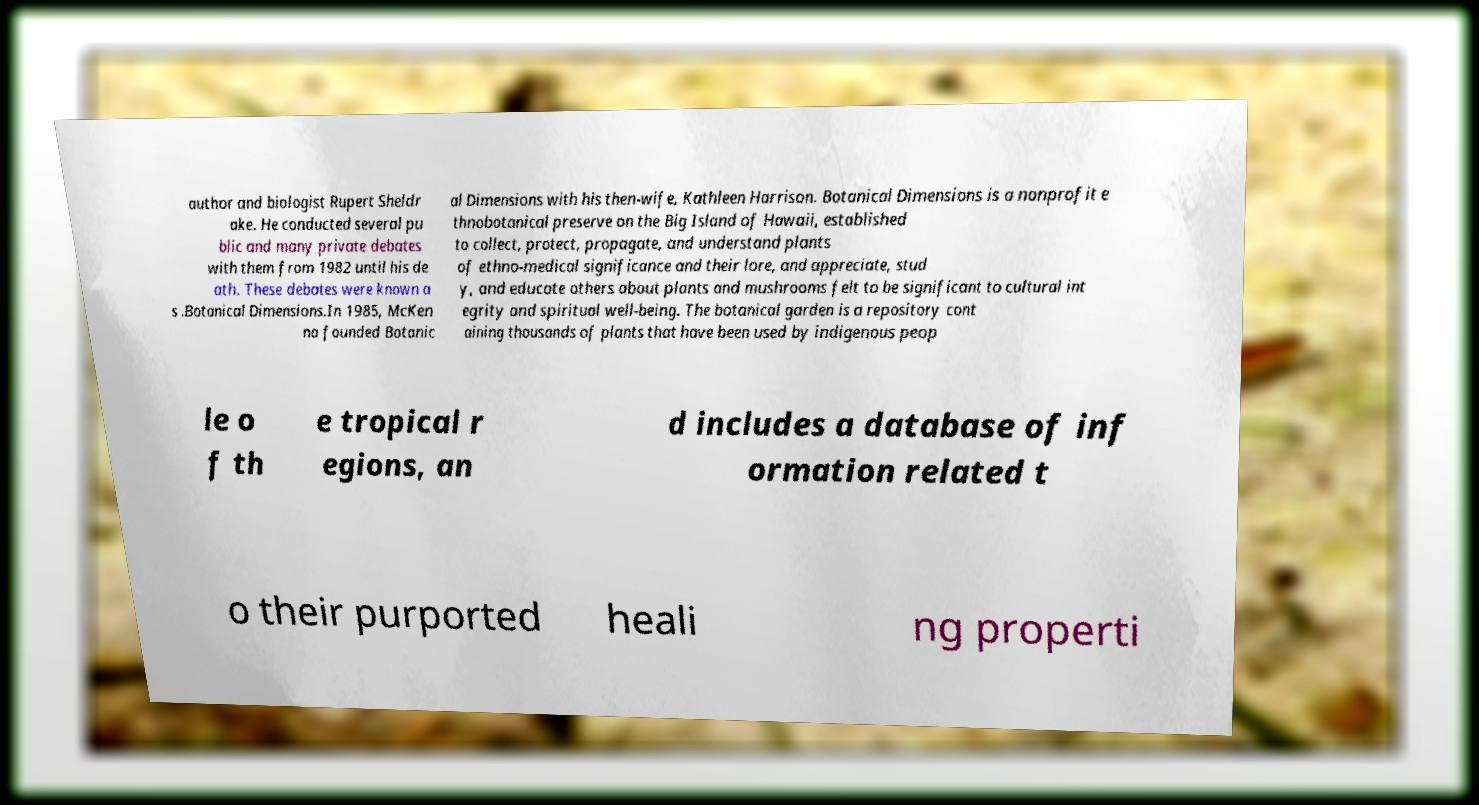Could you assist in decoding the text presented in this image and type it out clearly? author and biologist Rupert Sheldr ake. He conducted several pu blic and many private debates with them from 1982 until his de ath. These debates were known a s .Botanical Dimensions.In 1985, McKen na founded Botanic al Dimensions with his then-wife, Kathleen Harrison. Botanical Dimensions is a nonprofit e thnobotanical preserve on the Big Island of Hawaii, established to collect, protect, propagate, and understand plants of ethno-medical significance and their lore, and appreciate, stud y, and educate others about plants and mushrooms felt to be significant to cultural int egrity and spiritual well-being. The botanical garden is a repository cont aining thousands of plants that have been used by indigenous peop le o f th e tropical r egions, an d includes a database of inf ormation related t o their purported heali ng properti 